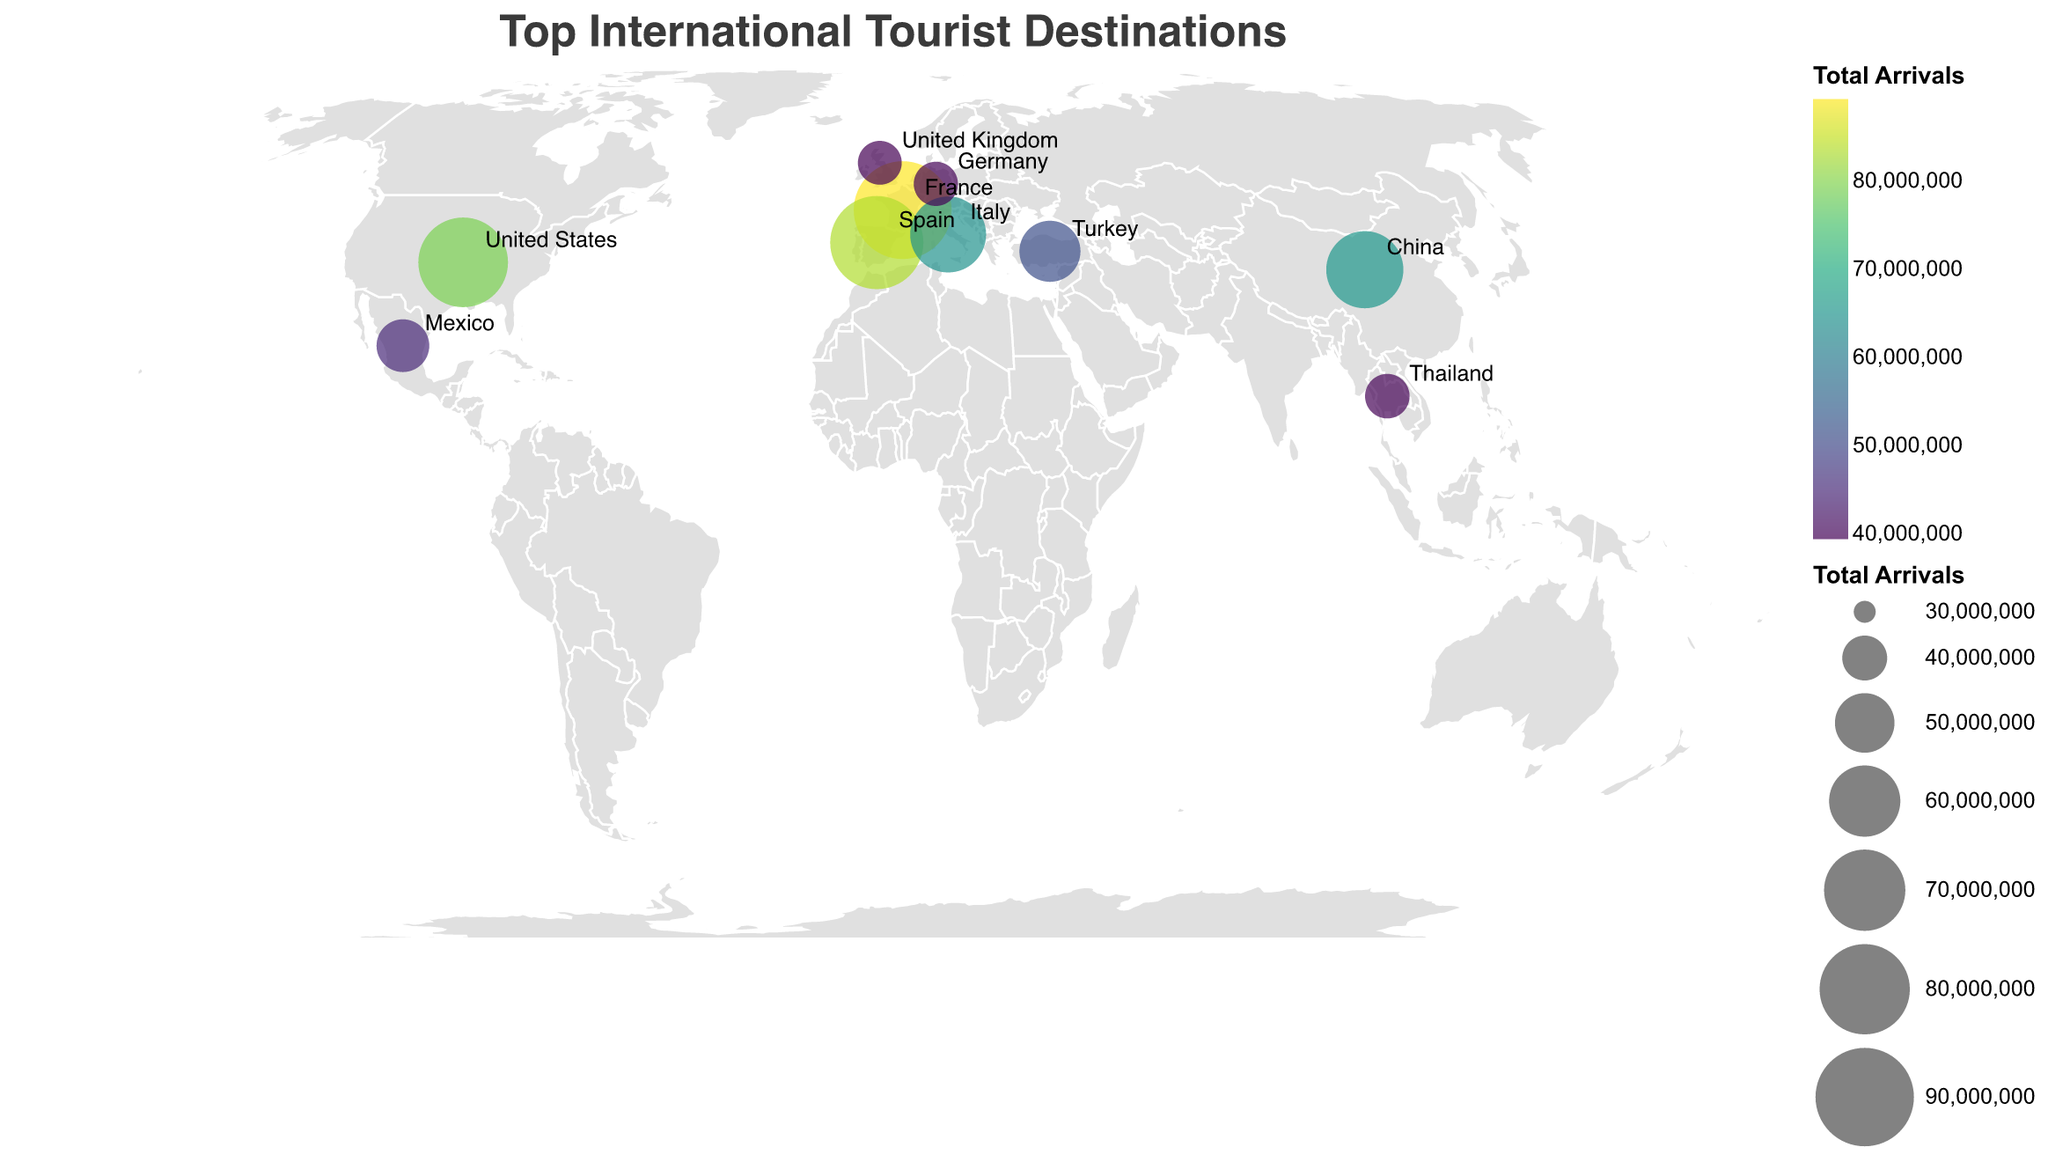How many countries are shown in the figure? The figure displays data points for different countries. By counting the data points, we see there are exactly ten countries depicted in the plot.
Answer: 10 Which country has the highest number of tourist arrivals? From the figure, the size and color intensity of the circles indicate the number of tourist arrivals. The largest and most intense circle corresponds to France.
Answer: France Which countries are the top source markets for tourists to the United States? By looking at the tooltip data for the United States, we can see that the top source markets are Canada, Mexico, the United Kingdom, and Japan.
Answer: Canada, Mexico, United Kingdom, Japan Between Spain and Italy, which country received more international tourist arrivals? Comparing the sizes and colors of the circles for Spain and Italy, it is clear that Spain has a larger and more intense circle, indicating that it received more international tourist arrivals than Italy.
Answer: Spain What is the average number of tourist arrivals in the listed countries? To find the average, sum the total arrivals for all countries and then divide by the number of countries: (89300000 + 83500000 + 79300000 + 65700000 + 64500000 + 51200000 + 45000000 + 39800000 + 39600000 + 39400000) / 10 = 557800000 / 10. So, the average is 55780000.
Answer: 55780000 Which country from the dataset attracts the most tourists from the United Kingdom? France is identified as the country with the largest completion in terms of arrivals from the United Kingdom according to the tooltip data for each country.
Answer: France How many countries have tourist arrivals less than 50,000,000? By examining the circles' sizes and tooltips, it's observed that there are three countries with tourist arrivals less than 50,000,000: Thailand, Germany, and the United Kingdom.
Answer: 3 Is the color intensity for tourist arrivals in Turkey higher than that in Mexico? The figure uses color intensity to represent the number of tourist arrivals. Observing the colors, Turkey’s color intensity is higher compared to Mexico's, indicating more tourist arrivals.
Answer: Yes Which country has similar tourist arrival numbers to Thailand but more than Germany? By comparing the sizes and colors of the circles, we see that Thailand and Germany are close in tourist arrival numbers, but Mexico is slightly higher, thus fitting the criteria.
Answer: Mexico What is the total number of tourist arrivals in European countries shown in the figure? Summing up the total arrivals for European countries (France, Spain, Italy, Turkey, Germany, United Kingdom): 89300000 + 83500000 + 64500000 + 51200000 + 39600000 + 39400000 = 367500000
Answer: 367500000 